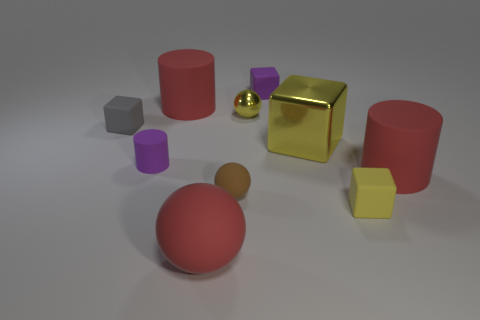Subtract all yellow spheres. How many yellow cubes are left? 2 Subtract all small yellow spheres. How many spheres are left? 2 Subtract all gray blocks. How many blocks are left? 3 Subtract 2 blocks. How many blocks are left? 2 Subtract all cubes. How many objects are left? 6 Subtract all tiny brown rubber objects. Subtract all tiny purple matte objects. How many objects are left? 7 Add 6 small yellow spheres. How many small yellow spheres are left? 7 Add 3 big yellow shiny things. How many big yellow shiny things exist? 4 Subtract 0 gray cylinders. How many objects are left? 10 Subtract all gray cylinders. Subtract all purple blocks. How many cylinders are left? 3 